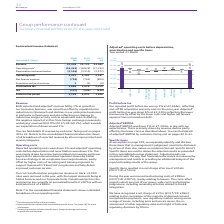According to Bt Group Plc's financial document, What was the change in the reported and adjusted revenue of Consumer business? According to the financial document, fell by 1%. The relevant text states: "Revenue Both reported and adjusted b revenue fell by 1% as growth in our Consumer business, was more than offset by regulated price reductions in Openreach..." Also, What was the reason for change in operating costs? mainly driven by restructuring related cost savings and lower payments to telecommunications operators driven by Global Services strategy to de-emphasise low margin business, partly offset by higher costs of recruiting and training engineers to support Openreach’s ‘Fibre First’ programme and help deliver improved customer service.. The document states: "preciation and amortisation were down 1%. This was mainly driven by restructuring related cost savings and lower payments to telecommunications operat..." Also, What is the revenue for 2017, 2018 and 2019 respectively? The document contains multiple relevant values: 24,062, 23,723, 23,428 (in millions). From the document: "Revenue 23,428 23,723 24,062 Revenue 23,428 23,723 24,062 Revenue 23,428 23,723 24,062..." Also, can you calculate: What is the change in the revenue from 2018 to 2019? Based on the calculation: 23,428 - 23,723, the result is -295 (in millions). This is based on the information: "Revenue 23,428 23,723 24,062 Revenue 23,428 23,723 24,062..." The key data points involved are: 23,428, 23,723. Also, can you calculate: What is the average operating costs for 2017-2019? To answer this question, I need to perform calculations using the financial data. The calculation is: -(16,461 + 16,828 + 17,323) / 3, which equals -16870.67 (in millions). This is based on the information: "Operating costs a (16,461) (16,828) (17,323) Operating costs a (16,461) (16,828) (17,323) Operating costs a (16,461) (16,828) (17,323)..." The key data points involved are: 16,461, 16,828, 17,323. Also, can you calculate: What is the average Depreciation and amortisation for 2017-2019? To answer this question, I need to perform calculations using the financial data. The calculation is: -(3,546 + 3,514 + 3,572) / 3, which equals -3544 (in millions). This is based on the information: "Depreciation and amortisation (3,546) (3,514) (3,572) Depreciation and amortisation (3,546) (3,514) (3,572) Depreciation and amortisation (3,546) (3,514) (3,572)..." The key data points involved are: 3,514, 3,546, 3,572. 